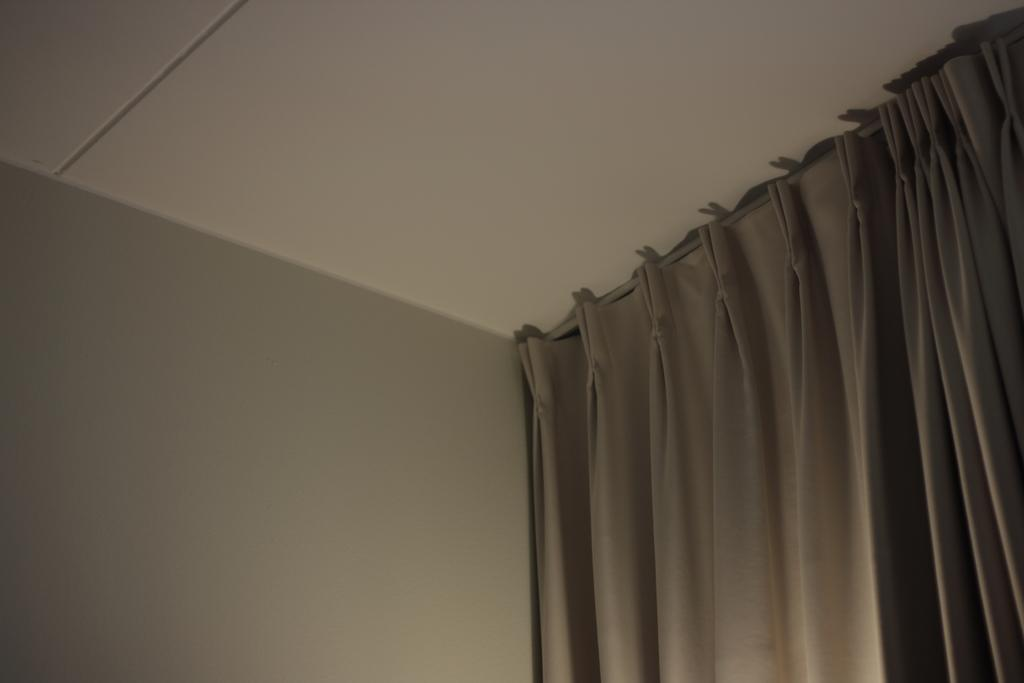What is hanging on a hanger in the image? There are curtains hanging on a hanger in the image. What type of structure is visible in the image? There is a roof visible in the image. What else can be seen in the image besides the roof? There is a wall visible in the image. Can you tell me where the locket is located in the image? There is no locket present in the image. How many mice can be seen running around in the image? There are no mice present in the image. 